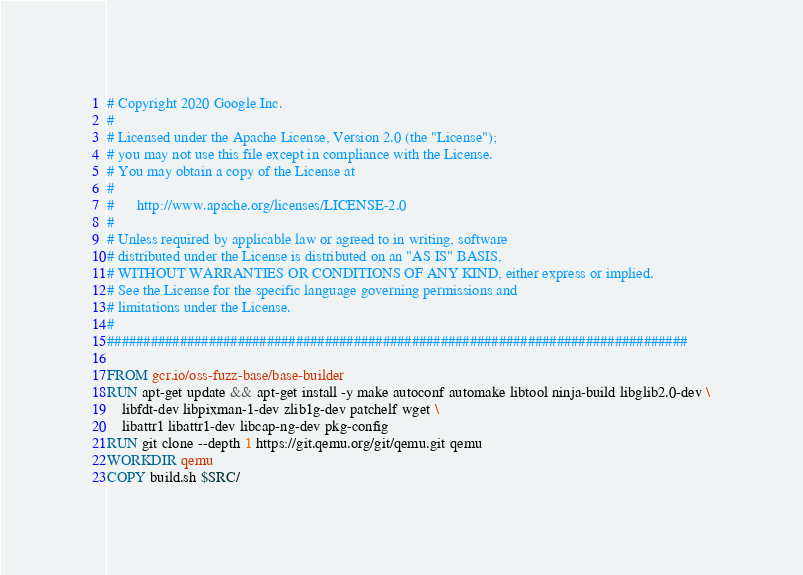Convert code to text. <code><loc_0><loc_0><loc_500><loc_500><_Dockerfile_># Copyright 2020 Google Inc.
#
# Licensed under the Apache License, Version 2.0 (the "License");
# you may not use this file except in compliance with the License.
# You may obtain a copy of the License at
#
#      http://www.apache.org/licenses/LICENSE-2.0
#
# Unless required by applicable law or agreed to in writing, software
# distributed under the License is distributed on an "AS IS" BASIS,
# WITHOUT WARRANTIES OR CONDITIONS OF ANY KIND, either express or implied.
# See the License for the specific language governing permissions and
# limitations under the License.
#
################################################################################

FROM gcr.io/oss-fuzz-base/base-builder
RUN apt-get update && apt-get install -y make autoconf automake libtool ninja-build libglib2.0-dev \
    libfdt-dev libpixman-1-dev zlib1g-dev patchelf wget \
    libattr1 libattr1-dev libcap-ng-dev pkg-config
RUN git clone --depth 1 https://git.qemu.org/git/qemu.git qemu
WORKDIR qemu
COPY build.sh $SRC/
</code> 